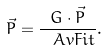<formula> <loc_0><loc_0><loc_500><loc_500>\vec { P } = \frac { { G } \cdot \vec { P } } { \ A v F i t } .</formula> 